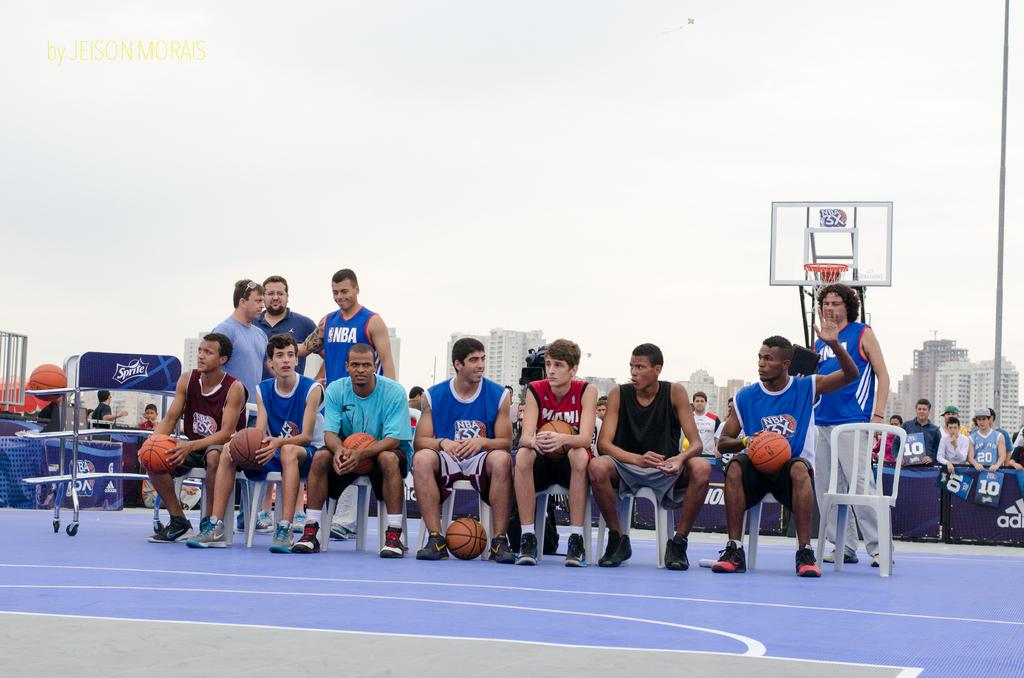<image>
Offer a succinct explanation of the picture presented. A group of baskeball players sit in chairs, one of whom is wearing a Miami jersey. 